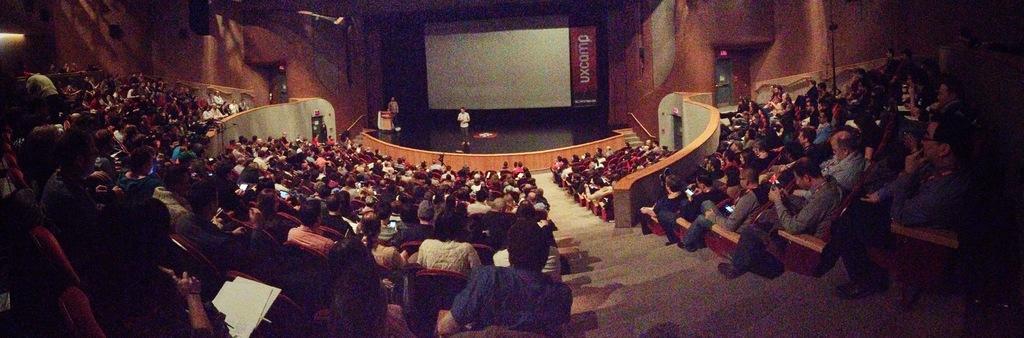Please provide a concise description of this image. On the right there are people sitting in chairs and there are wall, door, light and other objects. Towards left there are people, chairs, papers, doors and wall. In the center of picture there is a stage, on the stage there is a person. In the background there are podium, person, screen and wall. 